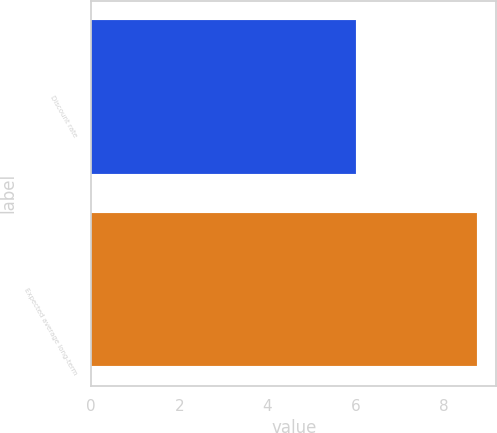Convert chart to OTSL. <chart><loc_0><loc_0><loc_500><loc_500><bar_chart><fcel>Discount rate<fcel>Expected average long-term<nl><fcel>6<fcel>8.75<nl></chart> 